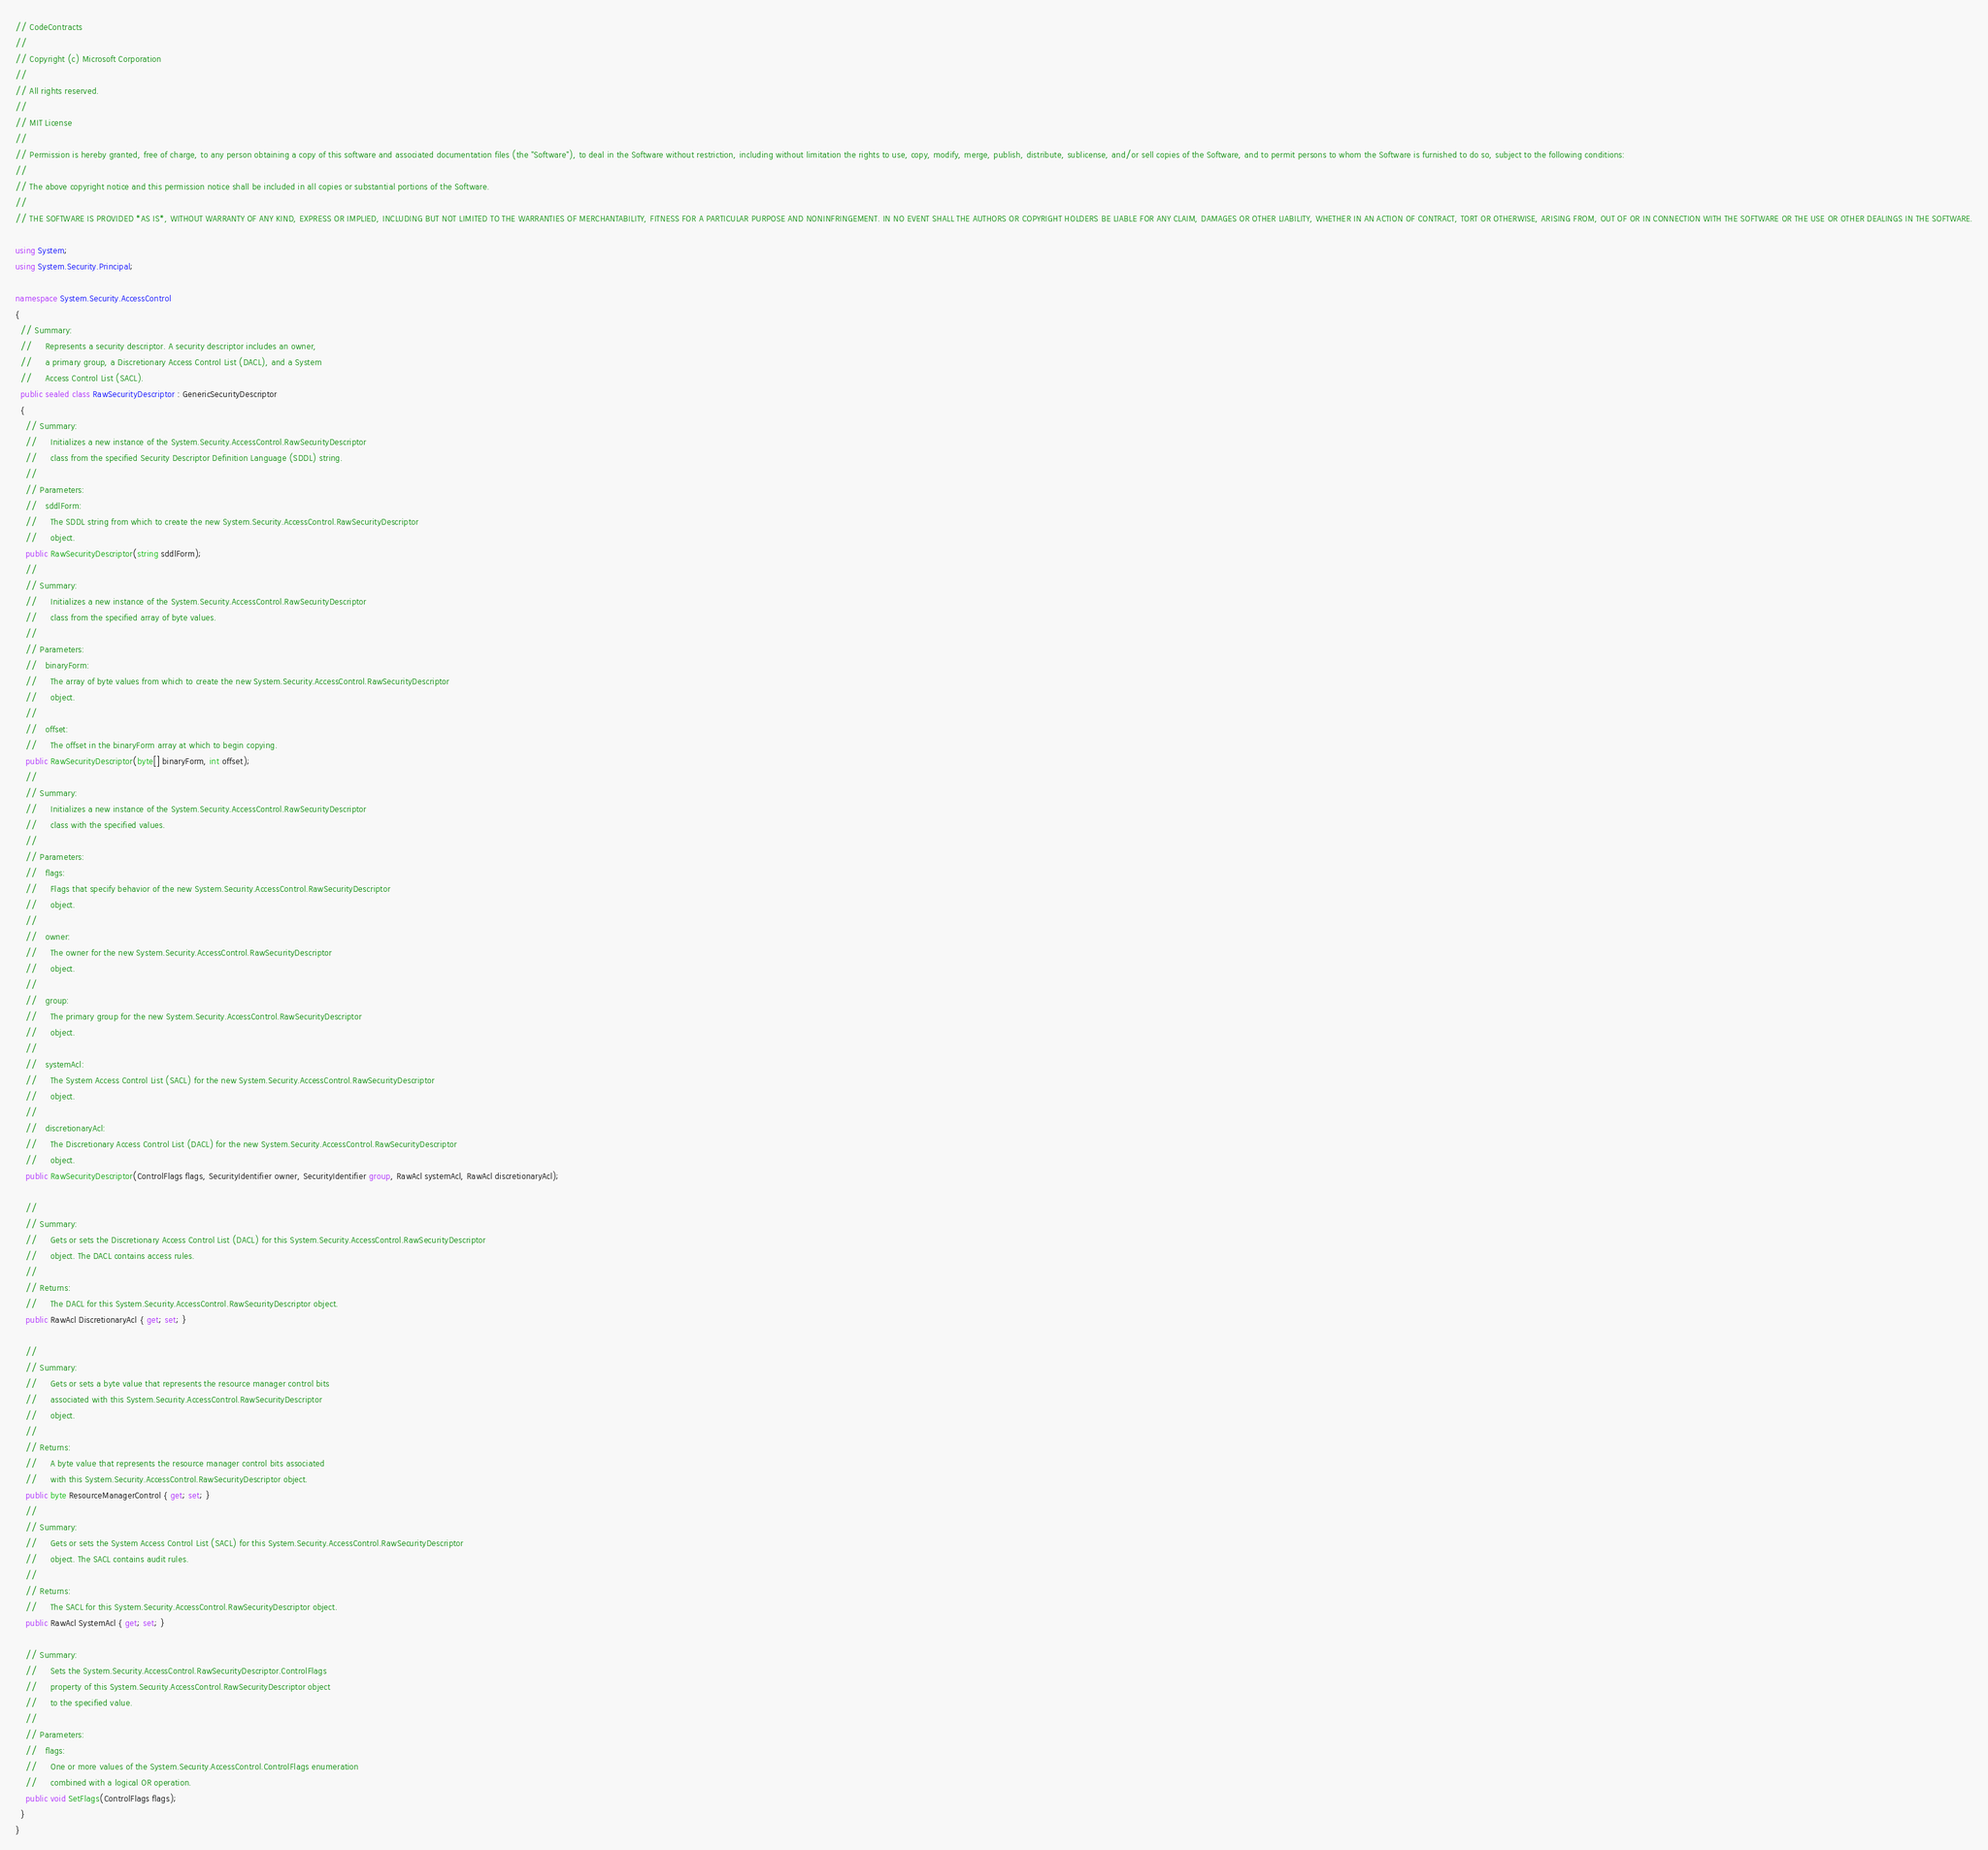Convert code to text. <code><loc_0><loc_0><loc_500><loc_500><_C#_>// CodeContracts
// 
// Copyright (c) Microsoft Corporation
// 
// All rights reserved. 
// 
// MIT License
// 
// Permission is hereby granted, free of charge, to any person obtaining a copy of this software and associated documentation files (the "Software"), to deal in the Software without restriction, including without limitation the rights to use, copy, modify, merge, publish, distribute, sublicense, and/or sell copies of the Software, and to permit persons to whom the Software is furnished to do so, subject to the following conditions:
// 
// The above copyright notice and this permission notice shall be included in all copies or substantial portions of the Software.
// 
// THE SOFTWARE IS PROVIDED *AS IS*, WITHOUT WARRANTY OF ANY KIND, EXPRESS OR IMPLIED, INCLUDING BUT NOT LIMITED TO THE WARRANTIES OF MERCHANTABILITY, FITNESS FOR A PARTICULAR PURPOSE AND NONINFRINGEMENT. IN NO EVENT SHALL THE AUTHORS OR COPYRIGHT HOLDERS BE LIABLE FOR ANY CLAIM, DAMAGES OR OTHER LIABILITY, WHETHER IN AN ACTION OF CONTRACT, TORT OR OTHERWISE, ARISING FROM, OUT OF OR IN CONNECTION WITH THE SOFTWARE OR THE USE OR OTHER DEALINGS IN THE SOFTWARE.

using System;
using System.Security.Principal;

namespace System.Security.AccessControl
{
  // Summary:
  //     Represents a security descriptor. A security descriptor includes an owner,
  //     a primary group, a Discretionary Access Control List (DACL), and a System
  //     Access Control List (SACL).
  public sealed class RawSecurityDescriptor : GenericSecurityDescriptor
  {
    // Summary:
    //     Initializes a new instance of the System.Security.AccessControl.RawSecurityDescriptor
    //     class from the specified Security Descriptor Definition Language (SDDL) string.
    //
    // Parameters:
    //   sddlForm:
    //     The SDDL string from which to create the new System.Security.AccessControl.RawSecurityDescriptor
    //     object.
    public RawSecurityDescriptor(string sddlForm);
    //
    // Summary:
    //     Initializes a new instance of the System.Security.AccessControl.RawSecurityDescriptor
    //     class from the specified array of byte values.
    //
    // Parameters:
    //   binaryForm:
    //     The array of byte values from which to create the new System.Security.AccessControl.RawSecurityDescriptor
    //     object.
    //
    //   offset:
    //     The offset in the binaryForm array at which to begin copying.
    public RawSecurityDescriptor(byte[] binaryForm, int offset);
    //
    // Summary:
    //     Initializes a new instance of the System.Security.AccessControl.RawSecurityDescriptor
    //     class with the specified values.
    //
    // Parameters:
    //   flags:
    //     Flags that specify behavior of the new System.Security.AccessControl.RawSecurityDescriptor
    //     object.
    //
    //   owner:
    //     The owner for the new System.Security.AccessControl.RawSecurityDescriptor
    //     object.
    //
    //   group:
    //     The primary group for the new System.Security.AccessControl.RawSecurityDescriptor
    //     object.
    //
    //   systemAcl:
    //     The System Access Control List (SACL) for the new System.Security.AccessControl.RawSecurityDescriptor
    //     object.
    //
    //   discretionaryAcl:
    //     The Discretionary Access Control List (DACL) for the new System.Security.AccessControl.RawSecurityDescriptor
    //     object.
    public RawSecurityDescriptor(ControlFlags flags, SecurityIdentifier owner, SecurityIdentifier group, RawAcl systemAcl, RawAcl discretionaryAcl);

    //
    // Summary:
    //     Gets or sets the Discretionary Access Control List (DACL) for this System.Security.AccessControl.RawSecurityDescriptor
    //     object. The DACL contains access rules.
    //
    // Returns:
    //     The DACL for this System.Security.AccessControl.RawSecurityDescriptor object.
    public RawAcl DiscretionaryAcl { get; set; }

    //
    // Summary:
    //     Gets or sets a byte value that represents the resource manager control bits
    //     associated with this System.Security.AccessControl.RawSecurityDescriptor
    //     object.
    //
    // Returns:
    //     A byte value that represents the resource manager control bits associated
    //     with this System.Security.AccessControl.RawSecurityDescriptor object.
    public byte ResourceManagerControl { get; set; }
    //
    // Summary:
    //     Gets or sets the System Access Control List (SACL) for this System.Security.AccessControl.RawSecurityDescriptor
    //     object. The SACL contains audit rules.
    //
    // Returns:
    //     The SACL for this System.Security.AccessControl.RawSecurityDescriptor object.
    public RawAcl SystemAcl { get; set; }

    // Summary:
    //     Sets the System.Security.AccessControl.RawSecurityDescriptor.ControlFlags
    //     property of this System.Security.AccessControl.RawSecurityDescriptor object
    //     to the specified value.
    //
    // Parameters:
    //   flags:
    //     One or more values of the System.Security.AccessControl.ControlFlags enumeration
    //     combined with a logical OR operation.
    public void SetFlags(ControlFlags flags);
  }
}
</code> 